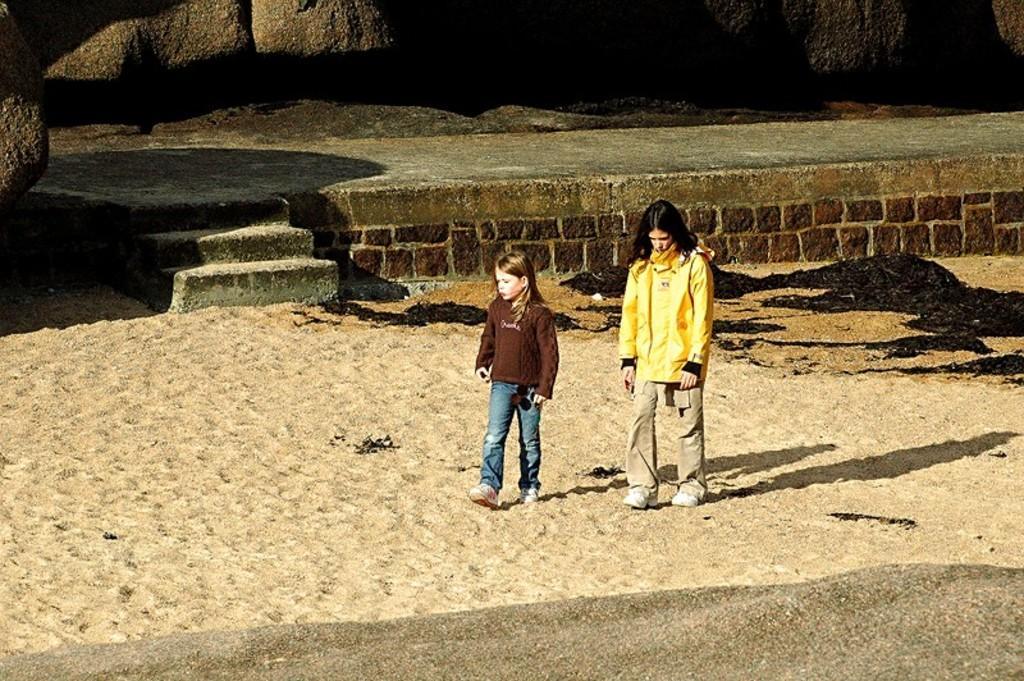Please provide a concise description of this image. In this image we can see two people standing on the sand. On the backside we can see a platform with staircase and some rocks. 